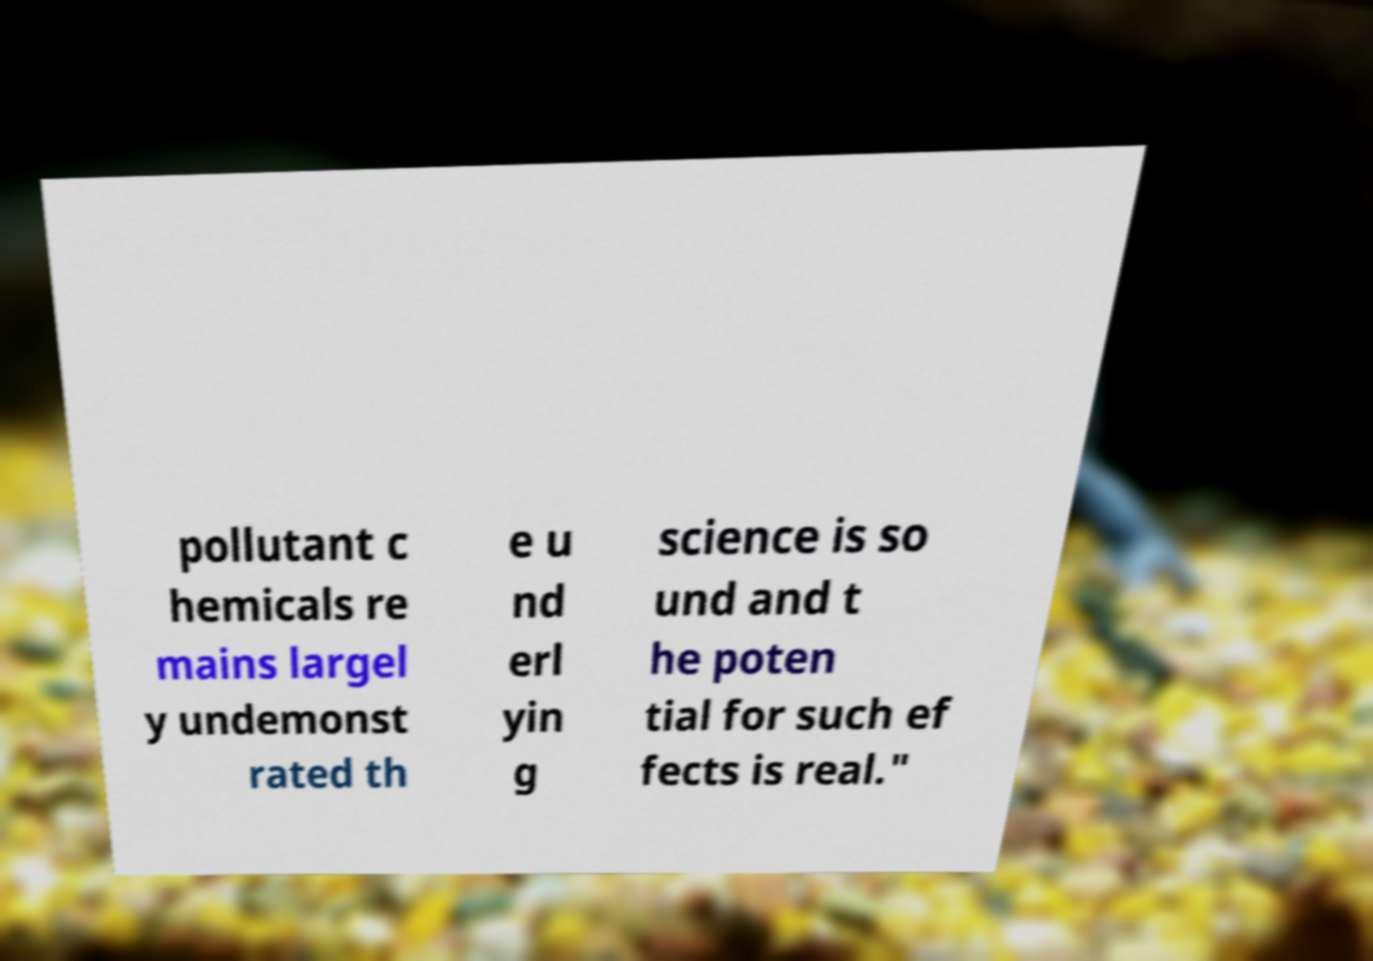For documentation purposes, I need the text within this image transcribed. Could you provide that? pollutant c hemicals re mains largel y undemonst rated th e u nd erl yin g science is so und and t he poten tial for such ef fects is real." 